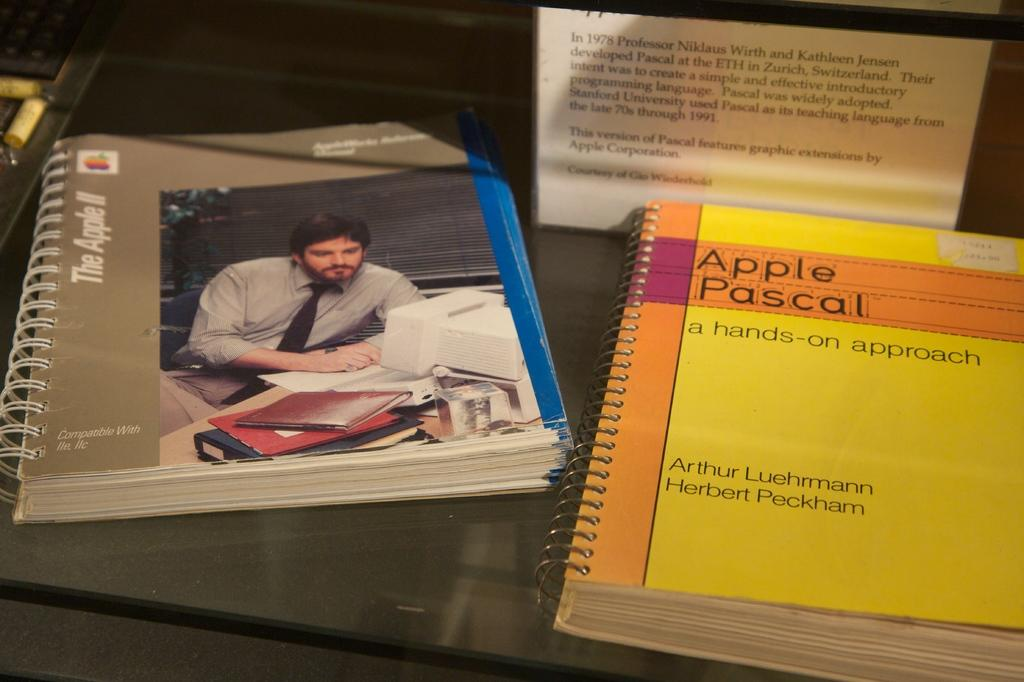<image>
Describe the image concisely. manual for apple IIc and IIe along with apple pascal book 